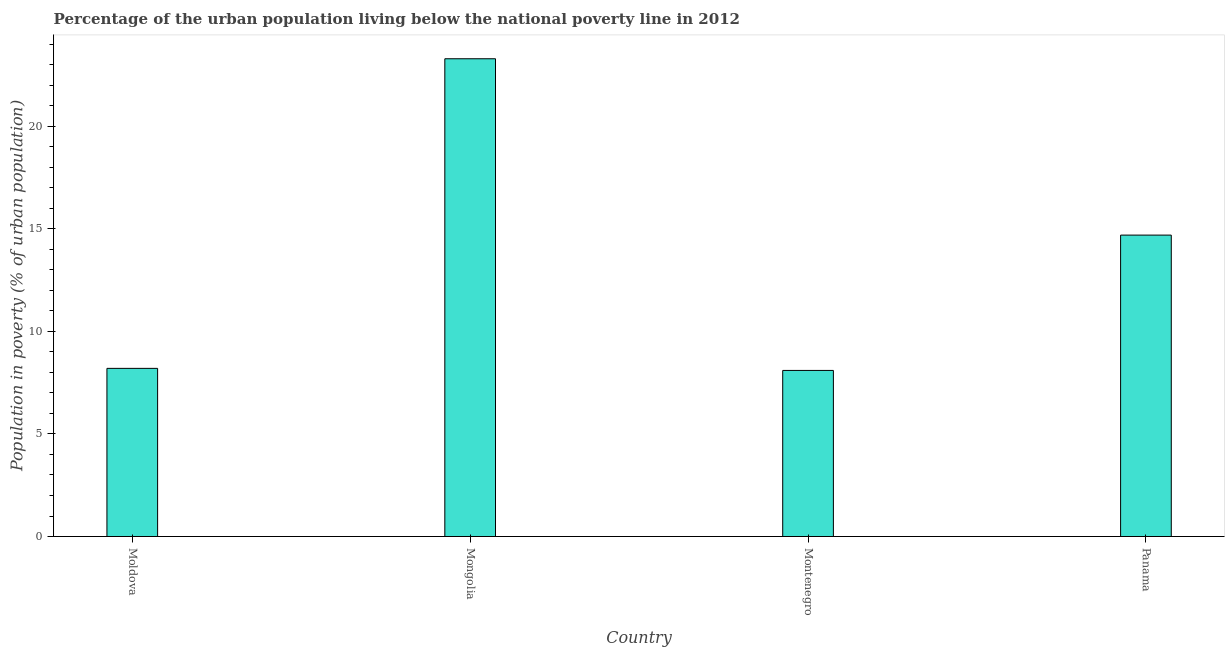What is the title of the graph?
Provide a short and direct response. Percentage of the urban population living below the national poverty line in 2012. What is the label or title of the X-axis?
Offer a terse response. Country. What is the label or title of the Y-axis?
Offer a very short reply. Population in poverty (% of urban population). Across all countries, what is the maximum percentage of urban population living below poverty line?
Offer a very short reply. 23.3. Across all countries, what is the minimum percentage of urban population living below poverty line?
Offer a very short reply. 8.1. In which country was the percentage of urban population living below poverty line maximum?
Your answer should be compact. Mongolia. In which country was the percentage of urban population living below poverty line minimum?
Give a very brief answer. Montenegro. What is the sum of the percentage of urban population living below poverty line?
Your answer should be compact. 54.3. What is the difference between the percentage of urban population living below poverty line in Moldova and Montenegro?
Ensure brevity in your answer.  0.1. What is the average percentage of urban population living below poverty line per country?
Give a very brief answer. 13.57. What is the median percentage of urban population living below poverty line?
Provide a short and direct response. 11.45. In how many countries, is the percentage of urban population living below poverty line greater than 18 %?
Offer a very short reply. 1. What is the ratio of the percentage of urban population living below poverty line in Moldova to that in Montenegro?
Your answer should be very brief. 1.01. Is the difference between the percentage of urban population living below poverty line in Mongolia and Montenegro greater than the difference between any two countries?
Your answer should be very brief. Yes. What is the difference between the highest and the second highest percentage of urban population living below poverty line?
Keep it short and to the point. 8.6. Is the sum of the percentage of urban population living below poverty line in Moldova and Mongolia greater than the maximum percentage of urban population living below poverty line across all countries?
Your response must be concise. Yes. What is the difference between the highest and the lowest percentage of urban population living below poverty line?
Ensure brevity in your answer.  15.2. What is the Population in poverty (% of urban population) in Mongolia?
Provide a succinct answer. 23.3. What is the difference between the Population in poverty (% of urban population) in Moldova and Mongolia?
Ensure brevity in your answer.  -15.1. What is the difference between the Population in poverty (% of urban population) in Moldova and Montenegro?
Your response must be concise. 0.1. What is the difference between the Population in poverty (% of urban population) in Moldova and Panama?
Keep it short and to the point. -6.5. What is the difference between the Population in poverty (% of urban population) in Montenegro and Panama?
Keep it short and to the point. -6.6. What is the ratio of the Population in poverty (% of urban population) in Moldova to that in Mongolia?
Provide a succinct answer. 0.35. What is the ratio of the Population in poverty (% of urban population) in Moldova to that in Montenegro?
Provide a short and direct response. 1.01. What is the ratio of the Population in poverty (% of urban population) in Moldova to that in Panama?
Make the answer very short. 0.56. What is the ratio of the Population in poverty (% of urban population) in Mongolia to that in Montenegro?
Your answer should be compact. 2.88. What is the ratio of the Population in poverty (% of urban population) in Mongolia to that in Panama?
Provide a succinct answer. 1.58. What is the ratio of the Population in poverty (% of urban population) in Montenegro to that in Panama?
Provide a succinct answer. 0.55. 